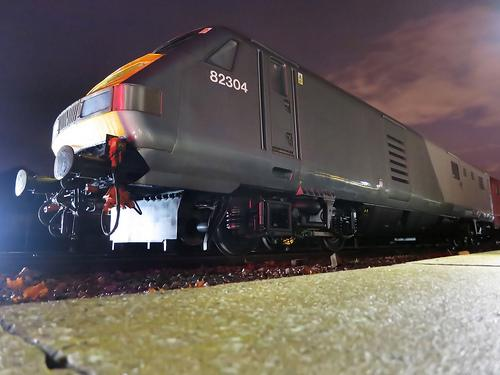Identify the rail transport vehicle depicted in the image. The image features a dark-colored locomotive with white numbering on its side. Mention the most visually dominant element in the image. The dark-colored locomotive engine is the most visually dominant element in the image. What can you see in the landscape surrounding the main subject in the image? The image shows a nighttime setting with the ground visible beneath the locomotive. Describe the general appearance and environment of the image. The image displays a locomotive at night, illuminated by ambient light, with a focus on the details of the train and the ground beneath it. Write a brief overview of the image content with a focus on the subject and its surroundings. The image shows a dark locomotive with white numbers on its side, captured at night with ambient lighting highlighting the details of the train and the ground. List the various parts and elements present within the image. The image includes a locomotive, white numbers, headlights, buffers, a coupling system, wheels, and the ground. Provide a brief description focusing on the primary object in the image. A dark-colored locomotive with white numbering on the side is prominently displayed. In a concise manner, report the most important features of the image. A dark locomotive with white numbers on the side, equipped with headlights and buffers, is featured in a nighttime setting. Briefly mention the colors visible in the image. Colors visible include dark gray, white, and the yellow of the headlights. Describe the front portion of the main subject in the image. The front of the locomotive features headlights, buffers, and a coupling system. 